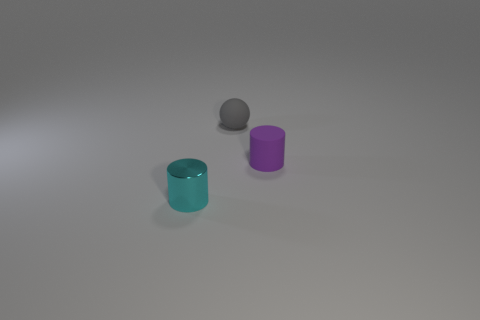What number of things are either small metallic cylinders or purple matte objects?
Offer a terse response. 2. Is the number of brown things less than the number of cylinders?
Keep it short and to the point. Yes. What is the size of the purple thing that is the same material as the tiny gray object?
Keep it short and to the point. Small. How big is the purple thing?
Keep it short and to the point. Small. The purple rubber thing has what shape?
Ensure brevity in your answer.  Cylinder. Is there any other thing that has the same material as the tiny cyan cylinder?
Your answer should be compact. No. There is a cylinder in front of the small matte cylinder in front of the gray matte ball; are there any rubber cylinders that are to the right of it?
Give a very brief answer. Yes. There is a small cylinder that is right of the tiny cyan metal cylinder; what material is it?
Provide a short and direct response. Rubber. What number of small objects are either cyan cylinders or spheres?
Offer a terse response. 2. How many other objects are there of the same color as the small rubber cylinder?
Give a very brief answer. 0. 